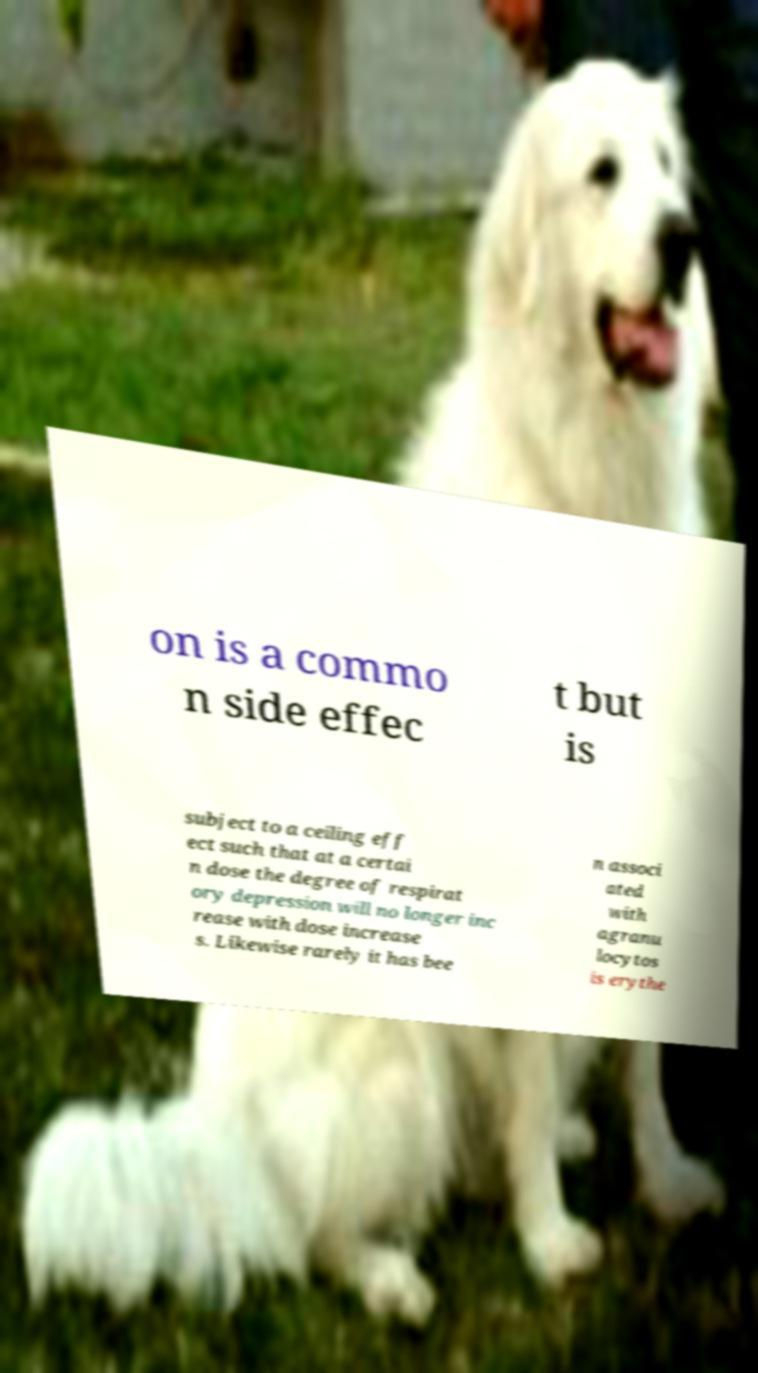Can you read and provide the text displayed in the image?This photo seems to have some interesting text. Can you extract and type it out for me? on is a commo n side effec t but is subject to a ceiling eff ect such that at a certai n dose the degree of respirat ory depression will no longer inc rease with dose increase s. Likewise rarely it has bee n associ ated with agranu locytos is erythe 